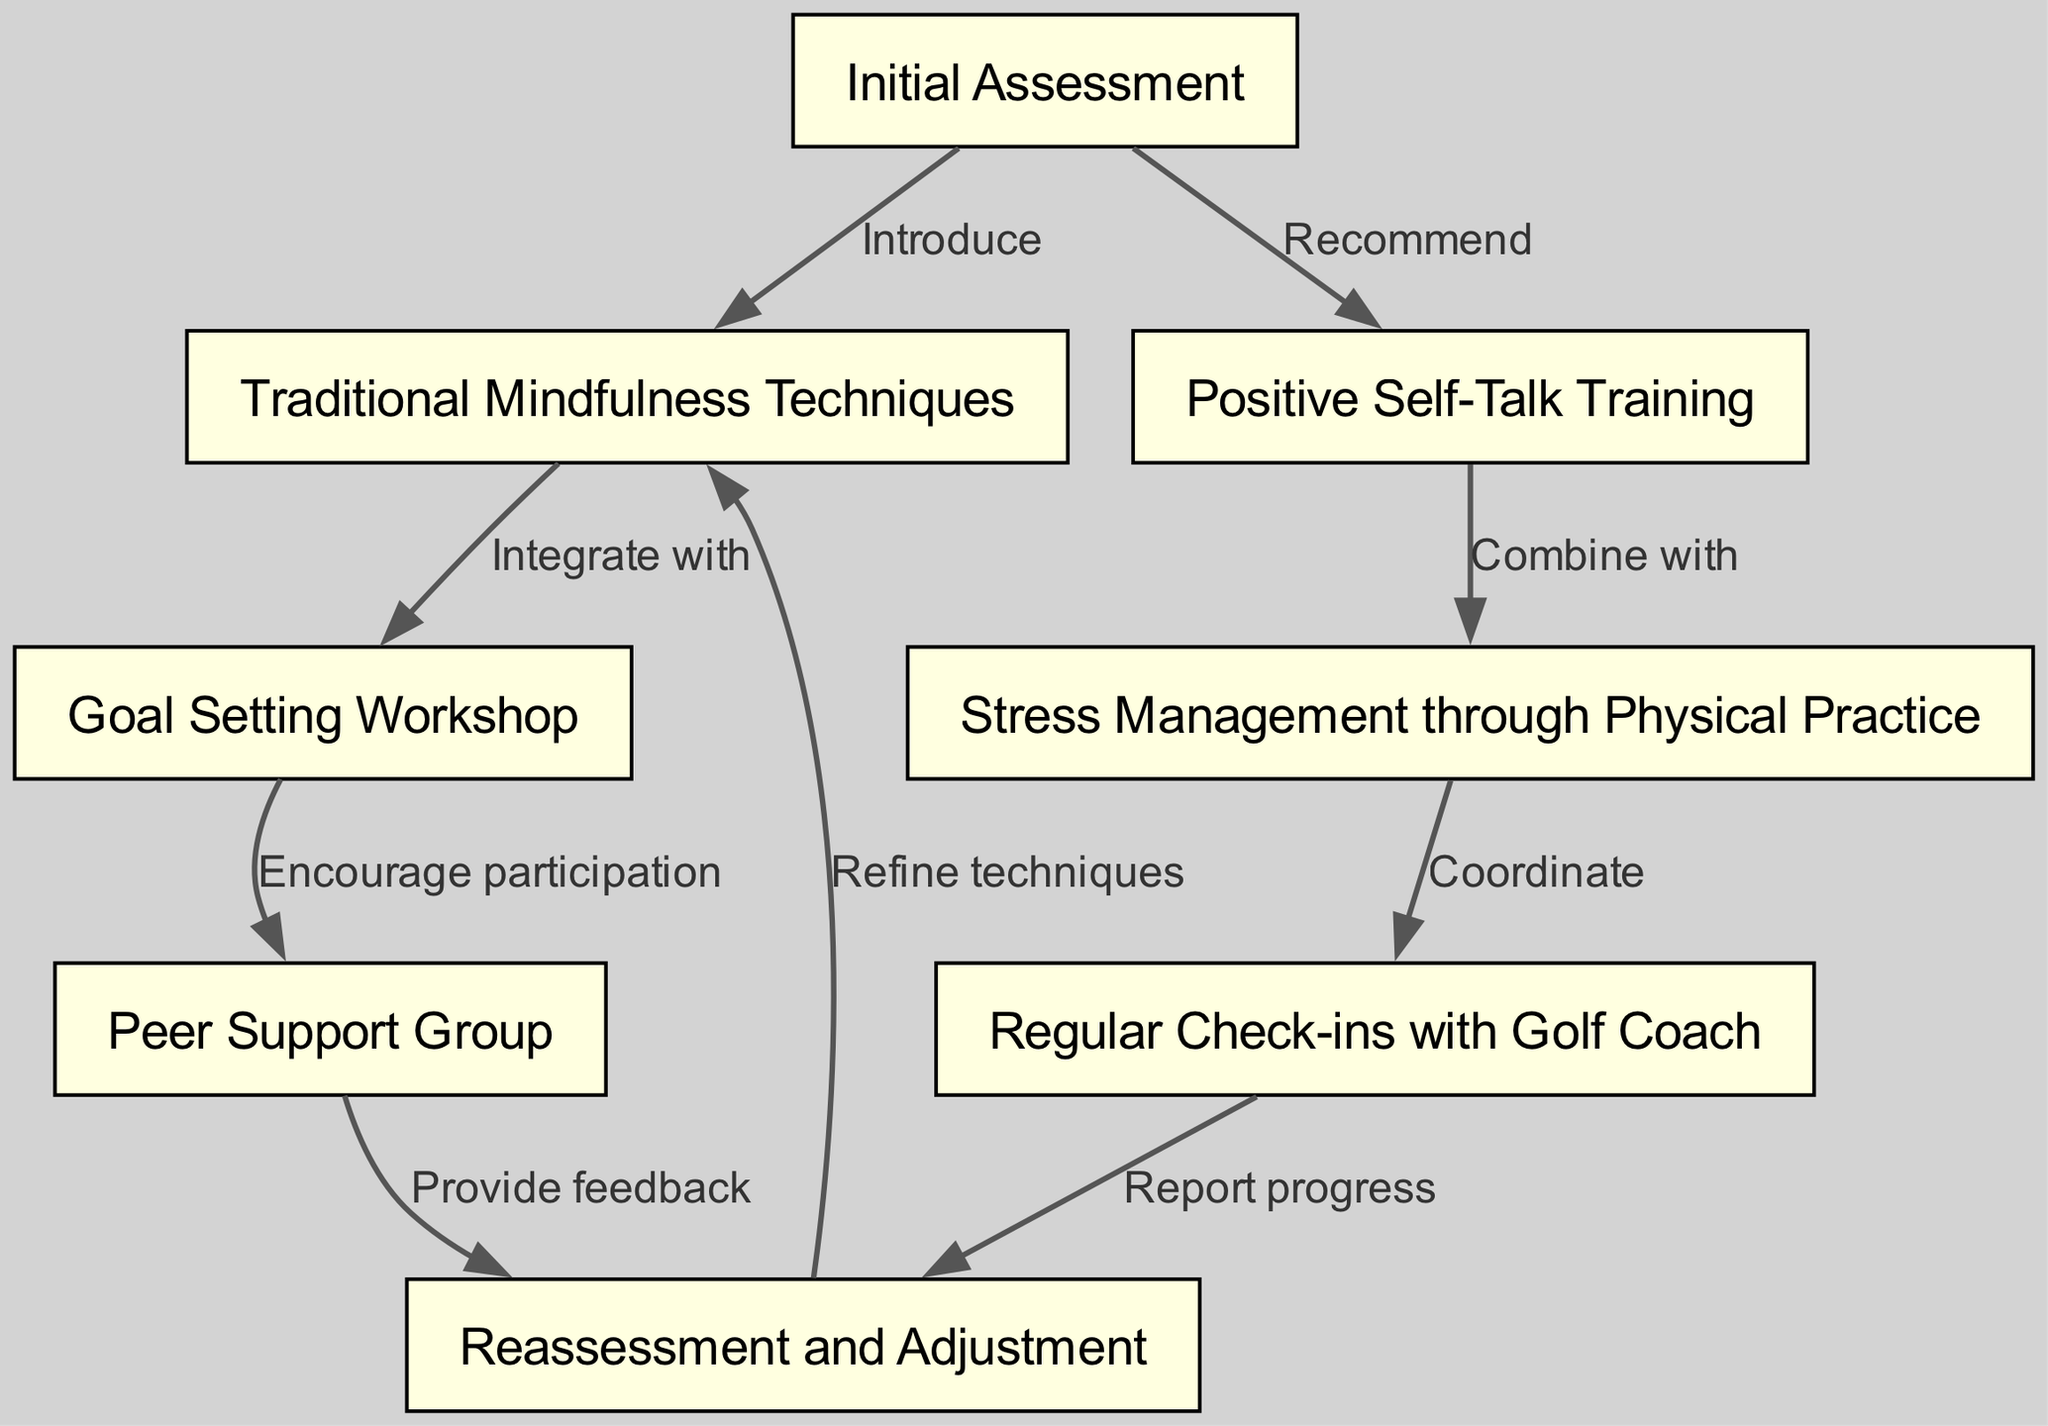What is the first step in the clinical pathway? The first node in the diagram is labeled "Initial Assessment," indicating that this comes first in the clinical pathway.
Answer: Initial Assessment How many nodes are in the diagram? By counting the nodes listed in the data, there are 8 nodes labeled from 1 to 8.
Answer: 8 Which nodes are connected by the edge labeled "Encourage participation"? The edge labeled "Encourage participation" connects the nodes "Goal Setting Workshop" and "Peer Support Group."
Answer: Goal Setting Workshop and Peer Support Group What is one technique integrated with "Traditional Mindfulness Techniques"? The edge labeled "Integrate with" shows that "Goal Setting Workshop" is a technique integrated with "Traditional Mindfulness Techniques."
Answer: Goal Setting Workshop What process follows "Regular Check-ins with Golf Coach"? Following the node "Regular Check-ins with Golf Coach," the next step in the pathway is "Reassessment and Adjustment."
Answer: Reassessment and Adjustment How does "Positive Self-Talk Training" relate to "Stress Management through Physical Practice"? "Positive Self-Talk Training" is combined with "Stress Management through Physical Practice," as indicated by the edge labeled "Combine with."
Answer: Combine with What feedback mechanism is offered after the "Peer Support Group"? The node "Peer Support Group" provides feedback for "Reassessment and Adjustment," as shown by the edge labeled "Provide feedback."
Answer: Provide feedback Which node is connected back to "Traditional Mindfulness Techniques" after reassessment? After reassessment, "Traditional Mindfulness Techniques" is refined, showcasing the edge labeled "Refine techniques" that connects to it.
Answer: Refine techniques 